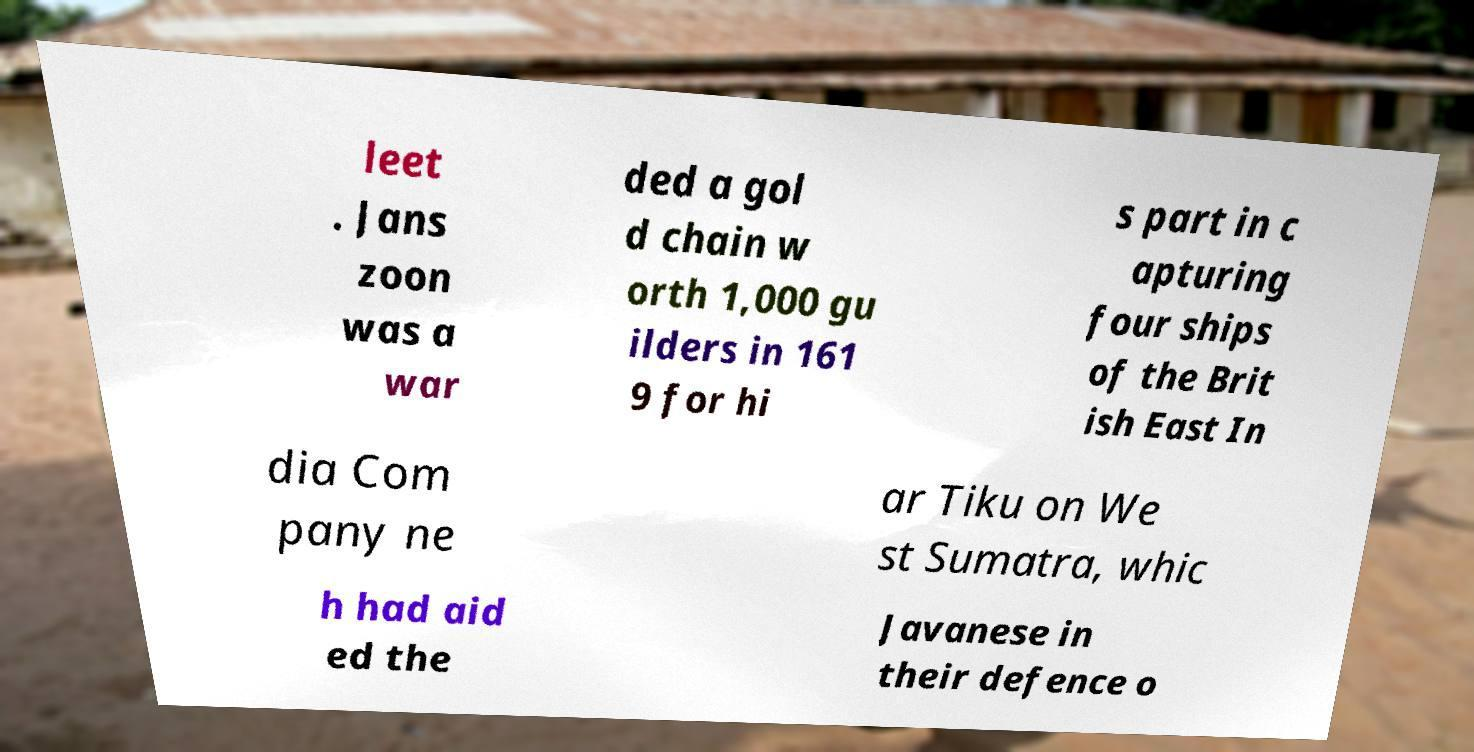I need the written content from this picture converted into text. Can you do that? leet . Jans zoon was a war ded a gol d chain w orth 1,000 gu ilders in 161 9 for hi s part in c apturing four ships of the Brit ish East In dia Com pany ne ar Tiku on We st Sumatra, whic h had aid ed the Javanese in their defence o 